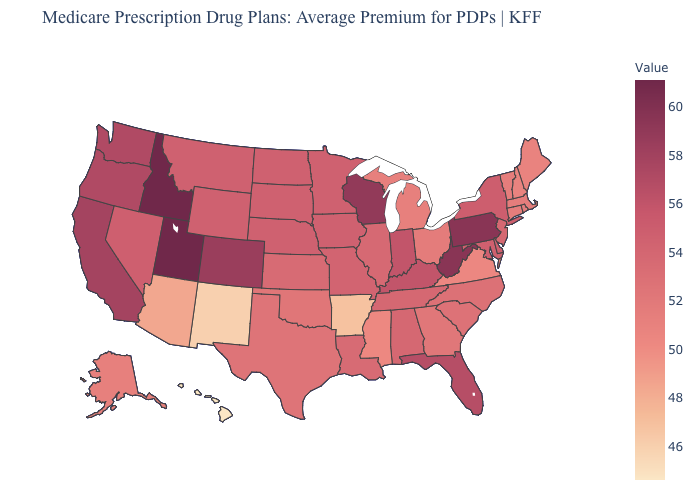Is the legend a continuous bar?
Keep it brief. Yes. Which states have the highest value in the USA?
Give a very brief answer. Idaho, Utah. Among the states that border Pennsylvania , does New Jersey have the highest value?
Concise answer only. No. Which states have the lowest value in the South?
Answer briefly. Arkansas. Which states have the lowest value in the USA?
Write a very short answer. Hawaii. Does the map have missing data?
Concise answer only. No. Does Arkansas have the lowest value in the South?
Keep it brief. Yes. Which states hav the highest value in the MidWest?
Write a very short answer. Wisconsin. Which states have the lowest value in the USA?
Short answer required. Hawaii. 